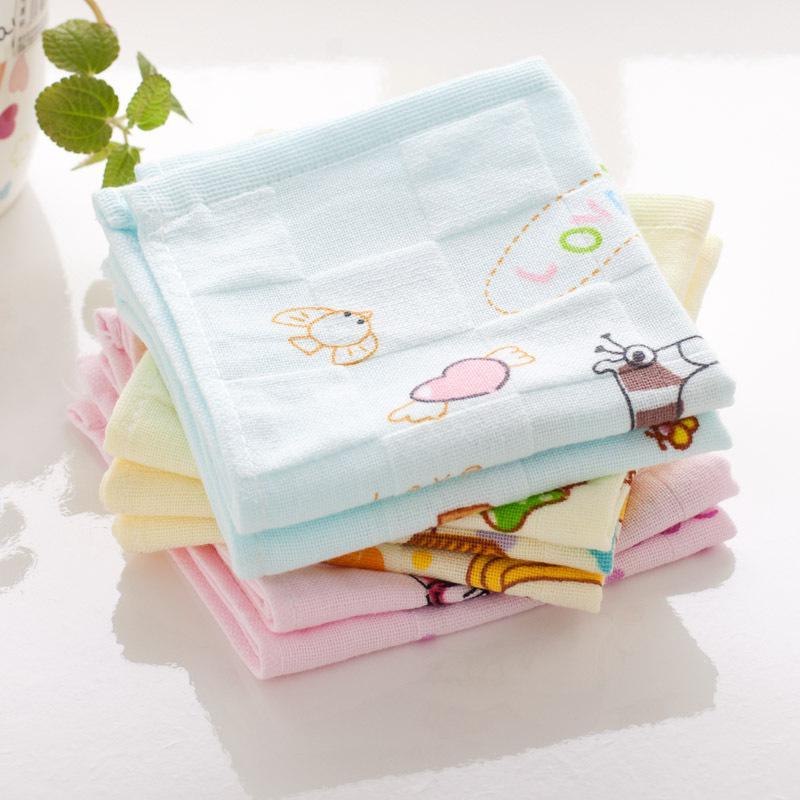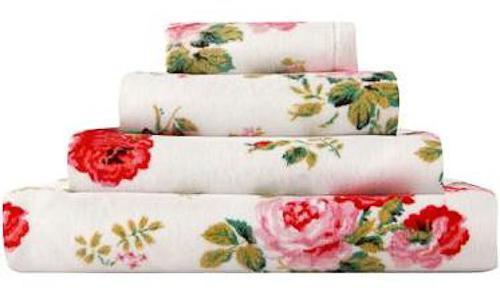The first image is the image on the left, the second image is the image on the right. Given the left and right images, does the statement "One image features only solid-colored towels in varying colors." hold true? Answer yes or no. No. 